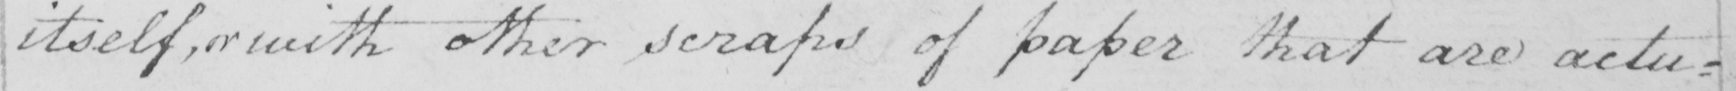Can you read and transcribe this handwriting? itself , or with other scraps of paper that are actu : 